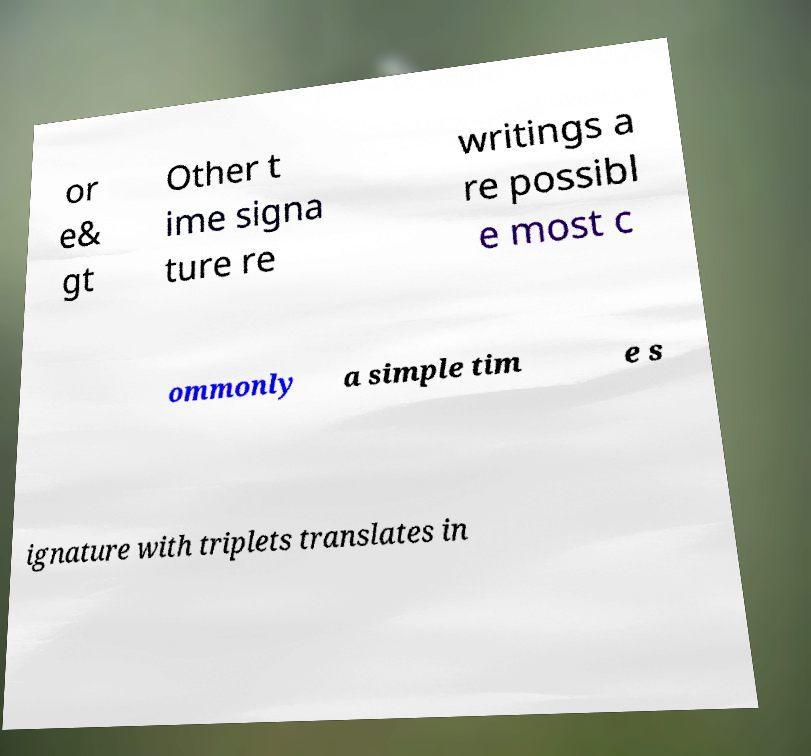Can you accurately transcribe the text from the provided image for me? or e& gt Other t ime signa ture re writings a re possibl e most c ommonly a simple tim e s ignature with triplets translates in 